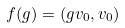Convert formula to latex. <formula><loc_0><loc_0><loc_500><loc_500>f ( g ) = ( g v _ { 0 } , v _ { 0 } )</formula> 